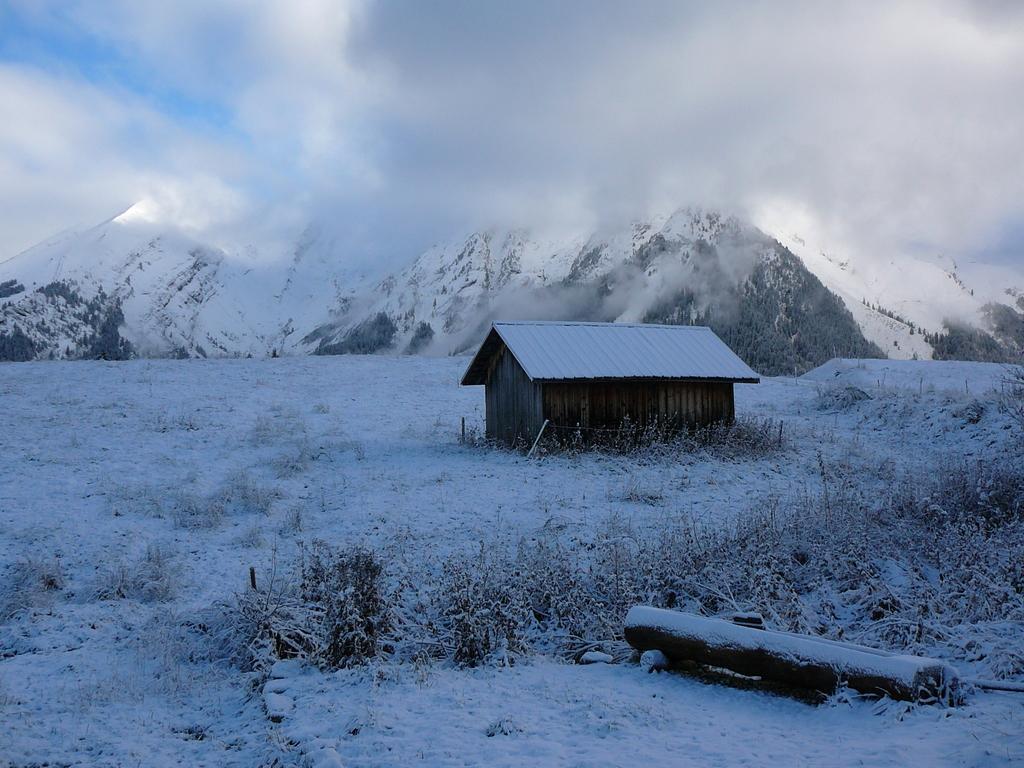How would you summarize this image in a sentence or two? In this image I can see a house. Background I can see the snow in white color, few mountains and the sky is in white and blue color. 